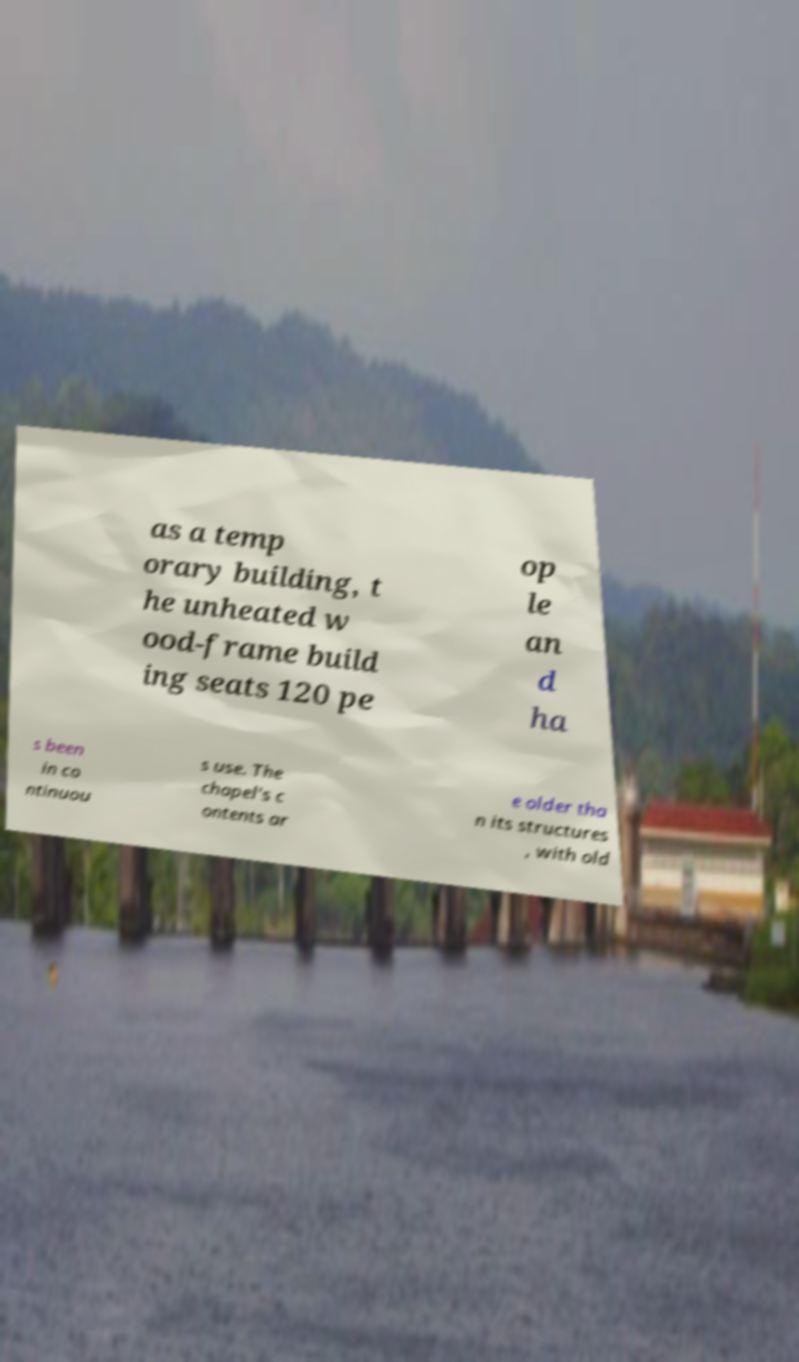Can you accurately transcribe the text from the provided image for me? as a temp orary building, t he unheated w ood-frame build ing seats 120 pe op le an d ha s been in co ntinuou s use. The chapel's c ontents ar e older tha n its structures , with old 